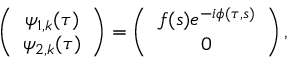<formula> <loc_0><loc_0><loc_500><loc_500>\left ( \begin{array} { c } { \psi _ { 1 , k } ( \tau ) } \\ { \psi _ { 2 , k } ( \tau ) } \end{array} \right ) = \left ( \begin{array} { c } { f ( s ) e ^ { - i \phi ( \tau , s ) } } \\ { 0 } \end{array} \right ) ,</formula> 